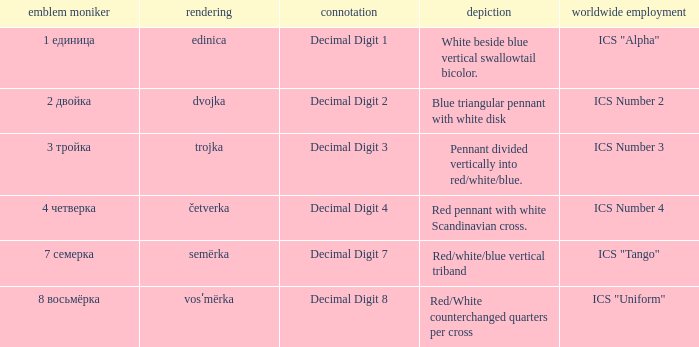What is the name of the flag that means decimal digit 2? 2 двойка. 